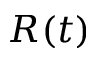<formula> <loc_0><loc_0><loc_500><loc_500>R ( t )</formula> 